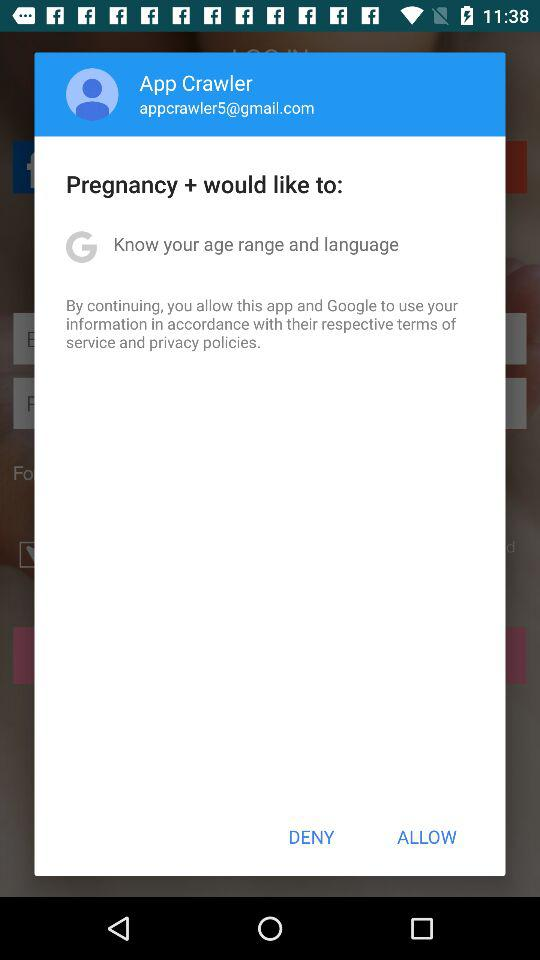What is the name of the user? The name of the user is App Crawler. 